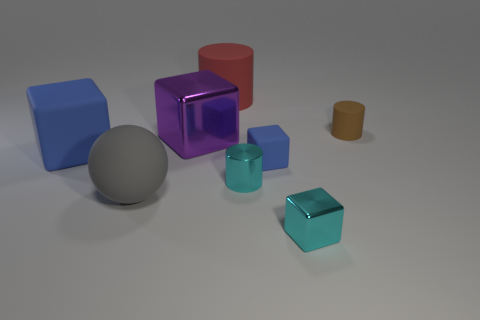Do the tiny rubber block and the big rubber cube have the same color? The tiny rubber block and the big rubber cube appear to have similar shades of blue. However, due to lighting and shadowing in the image, the colors may seem slightly different. Both objects reflect the same baseline color under consistent light conditions. 